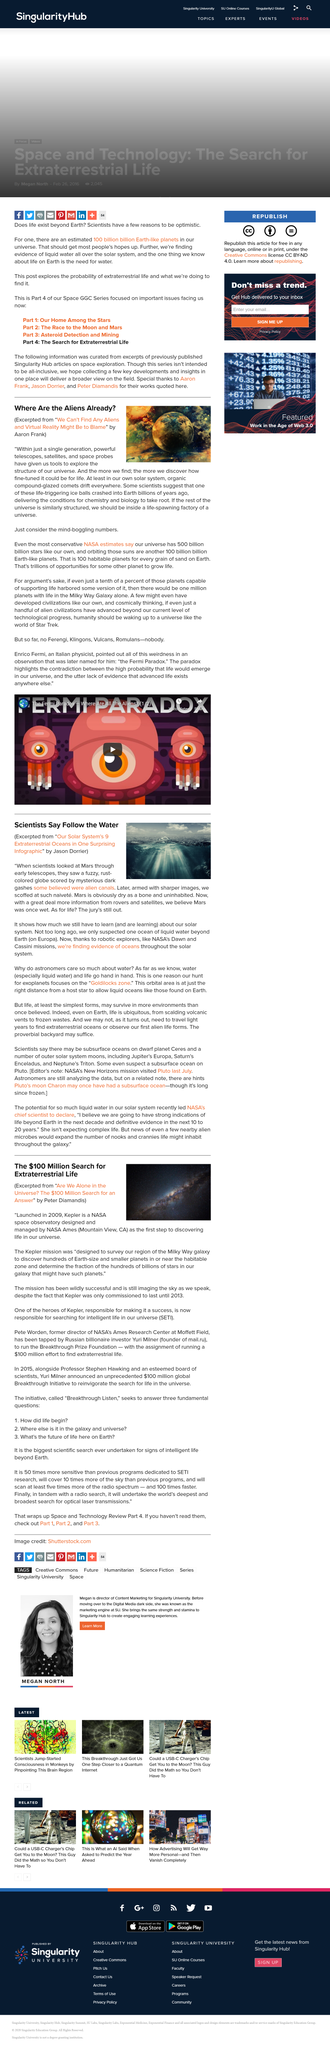List a handful of essential elements in this visual. The author of the excerpt is Aaron Frank. Mars was once a wet planet, according to scientists' new beliefs. Through a telescope, Mars appears as a fuzzy, rust-colored globe with dark gashes crisscrossing its surface, resembling a rugged and intriguing world beyond our planet. Scientists believe that a cataclysmic event, such as the impact of billions of ice balls, crashed into the Earth billions of years ago. In only a single generation, we have gained the tools to explore the very structure of the universe. 